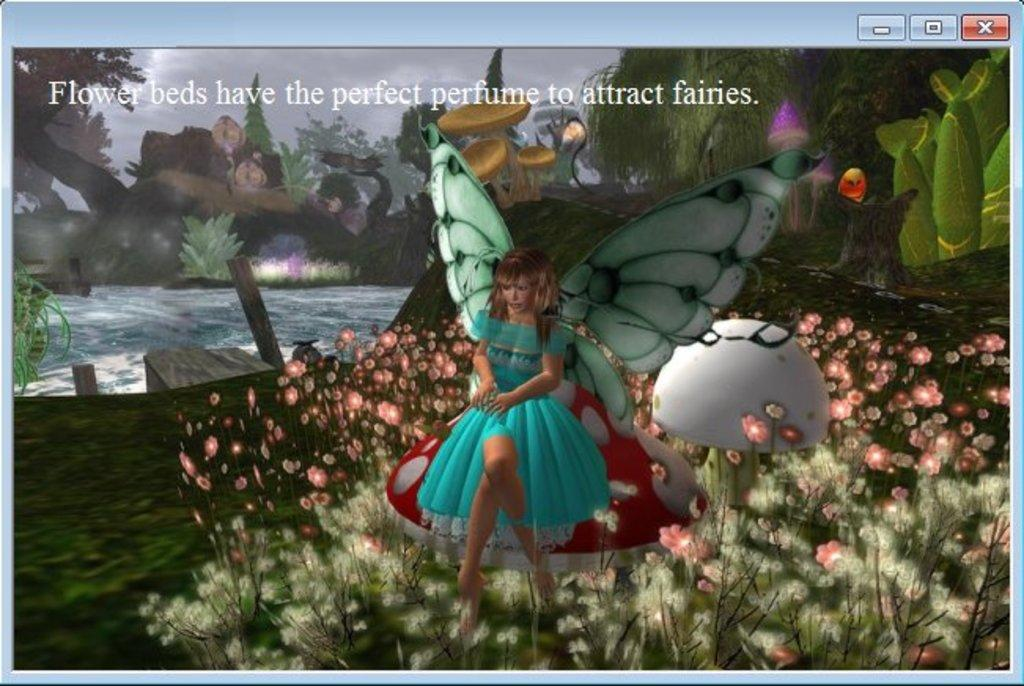What type of picture is the image? The image is an animation picture. What is present on the ground in the animation picture? There is ground in the animation picture. What type of vegetation can be seen in the animation picture? There are flowers and trees in the animation picture. What is the woman doing in the animation picture? The woman is sitting on a mushroom in the animation picture. What part of the natural environment is visible in the animation picture? The sky is visible in the animation picture. What type of lunchroom can be seen in the animation picture? There is no lunchroom present in the animation picture. How many beads are visible on the woman's necklace in the animation picture? There is no necklace or beads visible on the woman in the animation picture. 